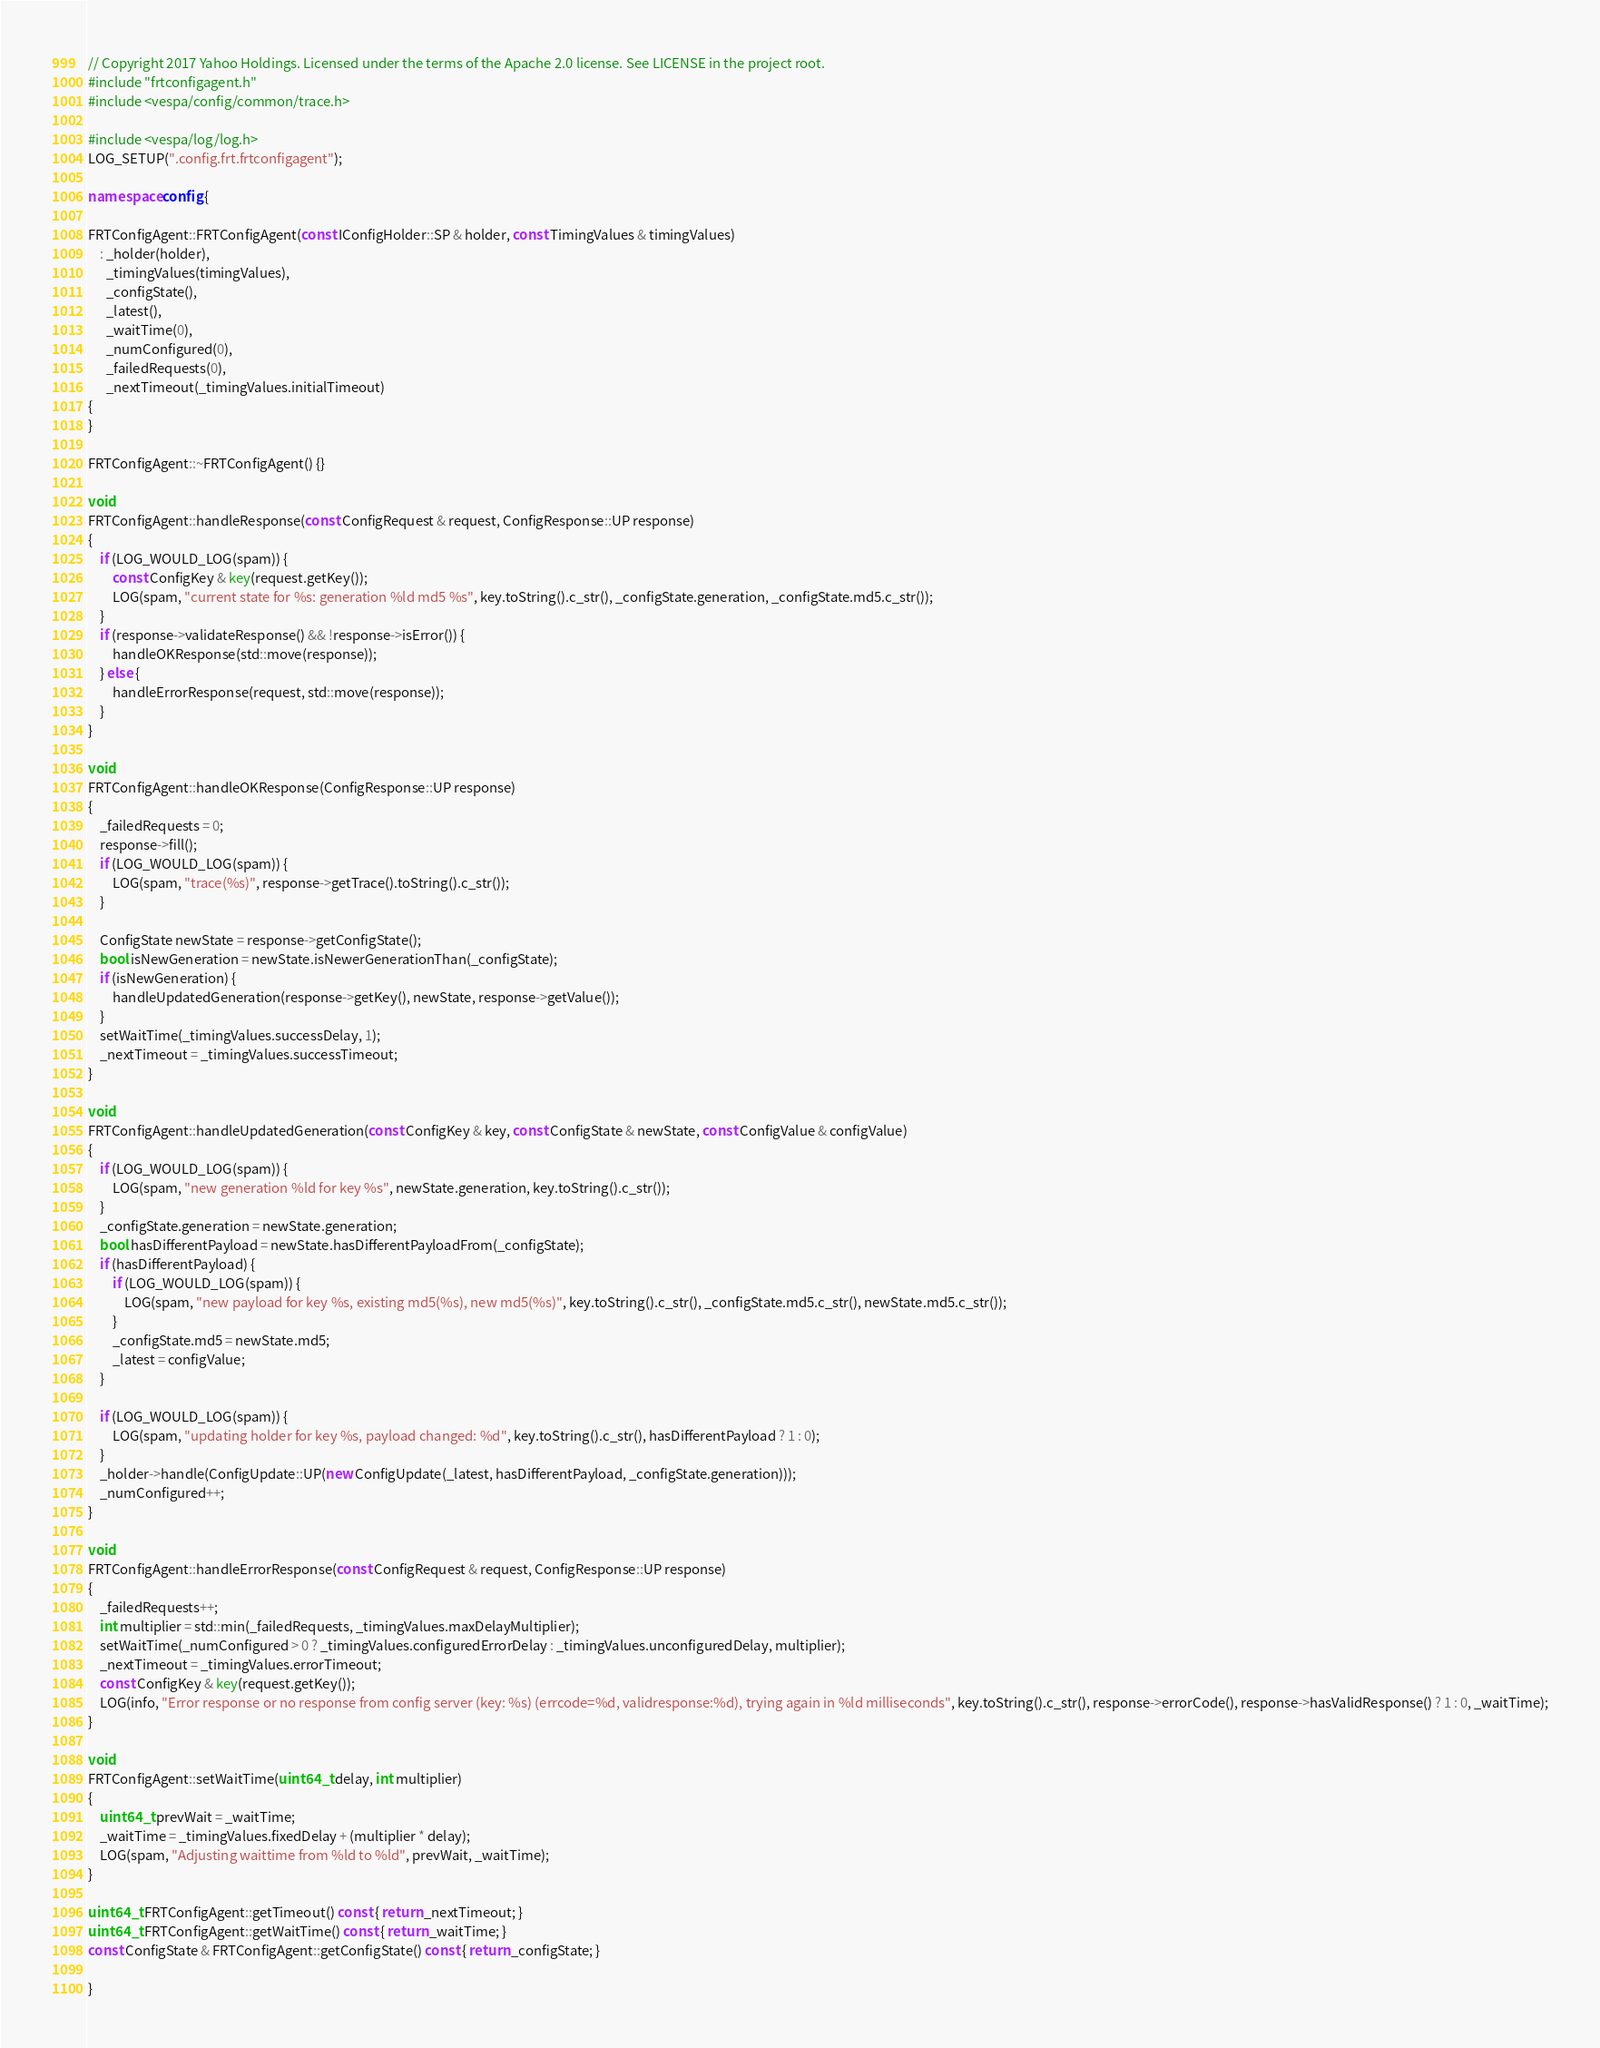Convert code to text. <code><loc_0><loc_0><loc_500><loc_500><_C++_>// Copyright 2017 Yahoo Holdings. Licensed under the terms of the Apache 2.0 license. See LICENSE in the project root.
#include "frtconfigagent.h"
#include <vespa/config/common/trace.h>

#include <vespa/log/log.h>
LOG_SETUP(".config.frt.frtconfigagent");

namespace config {

FRTConfigAgent::FRTConfigAgent(const IConfigHolder::SP & holder, const TimingValues & timingValues)
    : _holder(holder),
      _timingValues(timingValues),
      _configState(),
      _latest(),
      _waitTime(0),
      _numConfigured(0),
      _failedRequests(0),
      _nextTimeout(_timingValues.initialTimeout)
{
}

FRTConfigAgent::~FRTConfigAgent() {}

void
FRTConfigAgent::handleResponse(const ConfigRequest & request, ConfigResponse::UP response)
{
    if (LOG_WOULD_LOG(spam)) {
        const ConfigKey & key(request.getKey());
        LOG(spam, "current state for %s: generation %ld md5 %s", key.toString().c_str(), _configState.generation, _configState.md5.c_str());
    }
    if (response->validateResponse() && !response->isError()) {
        handleOKResponse(std::move(response));
    } else {
        handleErrorResponse(request, std::move(response));
    }
}

void
FRTConfigAgent::handleOKResponse(ConfigResponse::UP response)
{
    _failedRequests = 0;
    response->fill();
    if (LOG_WOULD_LOG(spam)) {
        LOG(spam, "trace(%s)", response->getTrace().toString().c_str());
    }

    ConfigState newState = response->getConfigState();
    bool isNewGeneration = newState.isNewerGenerationThan(_configState);
    if (isNewGeneration) {
        handleUpdatedGeneration(response->getKey(), newState, response->getValue());
    }
    setWaitTime(_timingValues.successDelay, 1);
    _nextTimeout = _timingValues.successTimeout;
}

void
FRTConfigAgent::handleUpdatedGeneration(const ConfigKey & key, const ConfigState & newState, const ConfigValue & configValue)
{
    if (LOG_WOULD_LOG(spam)) {
        LOG(spam, "new generation %ld for key %s", newState.generation, key.toString().c_str());
    }
    _configState.generation = newState.generation;
    bool hasDifferentPayload = newState.hasDifferentPayloadFrom(_configState);
    if (hasDifferentPayload) {
        if (LOG_WOULD_LOG(spam)) {
            LOG(spam, "new payload for key %s, existing md5(%s), new md5(%s)", key.toString().c_str(), _configState.md5.c_str(), newState.md5.c_str());
        }
        _configState.md5 = newState.md5;
        _latest = configValue;
    }

    if (LOG_WOULD_LOG(spam)) {
        LOG(spam, "updating holder for key %s, payload changed: %d", key.toString().c_str(), hasDifferentPayload ? 1 : 0);
    }
    _holder->handle(ConfigUpdate::UP(new ConfigUpdate(_latest, hasDifferentPayload, _configState.generation)));
    _numConfigured++;
}

void
FRTConfigAgent::handleErrorResponse(const ConfigRequest & request, ConfigResponse::UP response)
{
    _failedRequests++;
    int multiplier = std::min(_failedRequests, _timingValues.maxDelayMultiplier);
    setWaitTime(_numConfigured > 0 ? _timingValues.configuredErrorDelay : _timingValues.unconfiguredDelay, multiplier);
    _nextTimeout = _timingValues.errorTimeout;
    const ConfigKey & key(request.getKey());
    LOG(info, "Error response or no response from config server (key: %s) (errcode=%d, validresponse:%d), trying again in %ld milliseconds", key.toString().c_str(), response->errorCode(), response->hasValidResponse() ? 1 : 0, _waitTime);
}

void
FRTConfigAgent::setWaitTime(uint64_t delay, int multiplier)
{
    uint64_t prevWait = _waitTime;
    _waitTime = _timingValues.fixedDelay + (multiplier * delay);
    LOG(spam, "Adjusting waittime from %ld to %ld", prevWait, _waitTime);
}

uint64_t FRTConfigAgent::getTimeout() const { return _nextTimeout; }
uint64_t FRTConfigAgent::getWaitTime() const { return _waitTime; }
const ConfigState & FRTConfigAgent::getConfigState() const { return _configState; }

}
</code> 